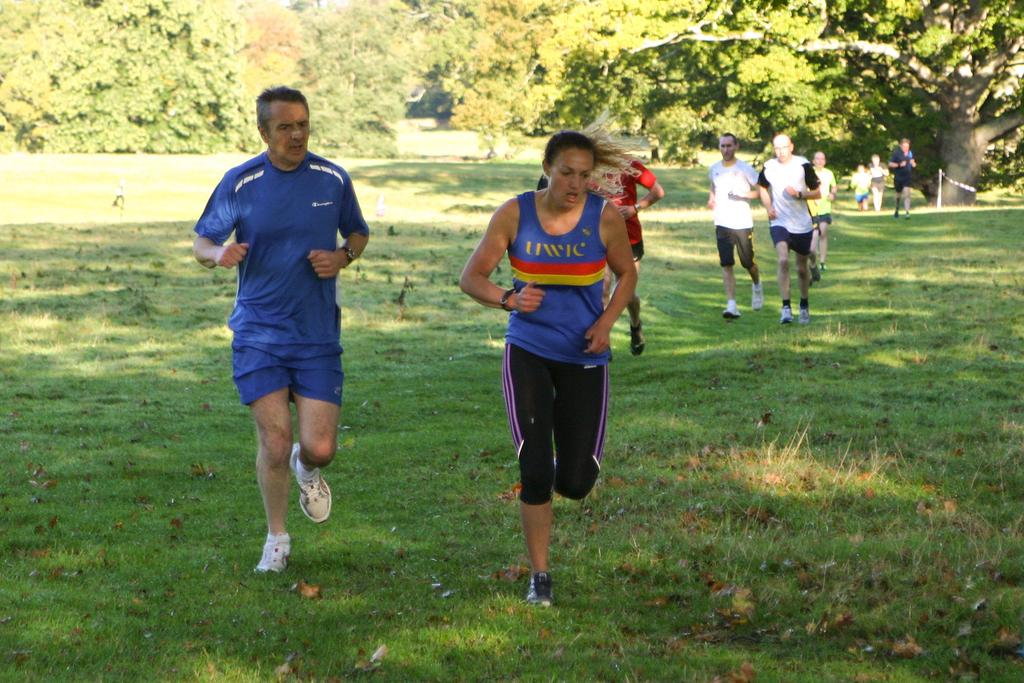What are the groups of people doing in the image? The groups of people are running in the image. What type of surface are the people running on? There is grass visible in the image, which is the surface they are running on. What type of vegetation is present in the image? There are trees with branches and leaves in the image. What type of net can be seen catching the liquid in the image? There is no net or liquid present in the image; it features groups of people running on grass with trees in the background. What type of quiver is visible on the people running in the image? There is no quiver visible on the people running in the image. 